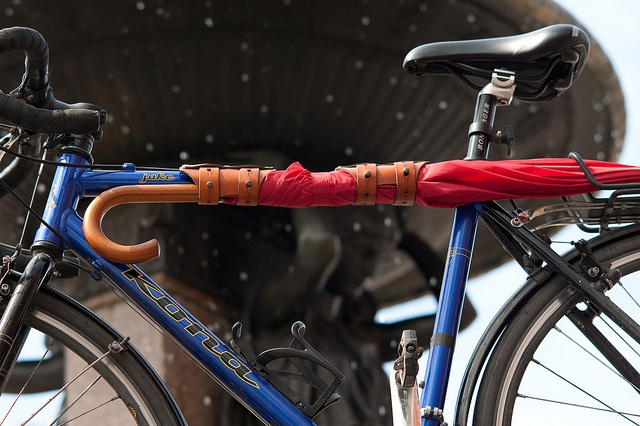Describe the objects in this image and their specific colors. I can see bicycle in black, white, maroon, and gray tones, people in black, gray, and white tones, and umbrella in black, maroon, brown, and salmon tones in this image. 